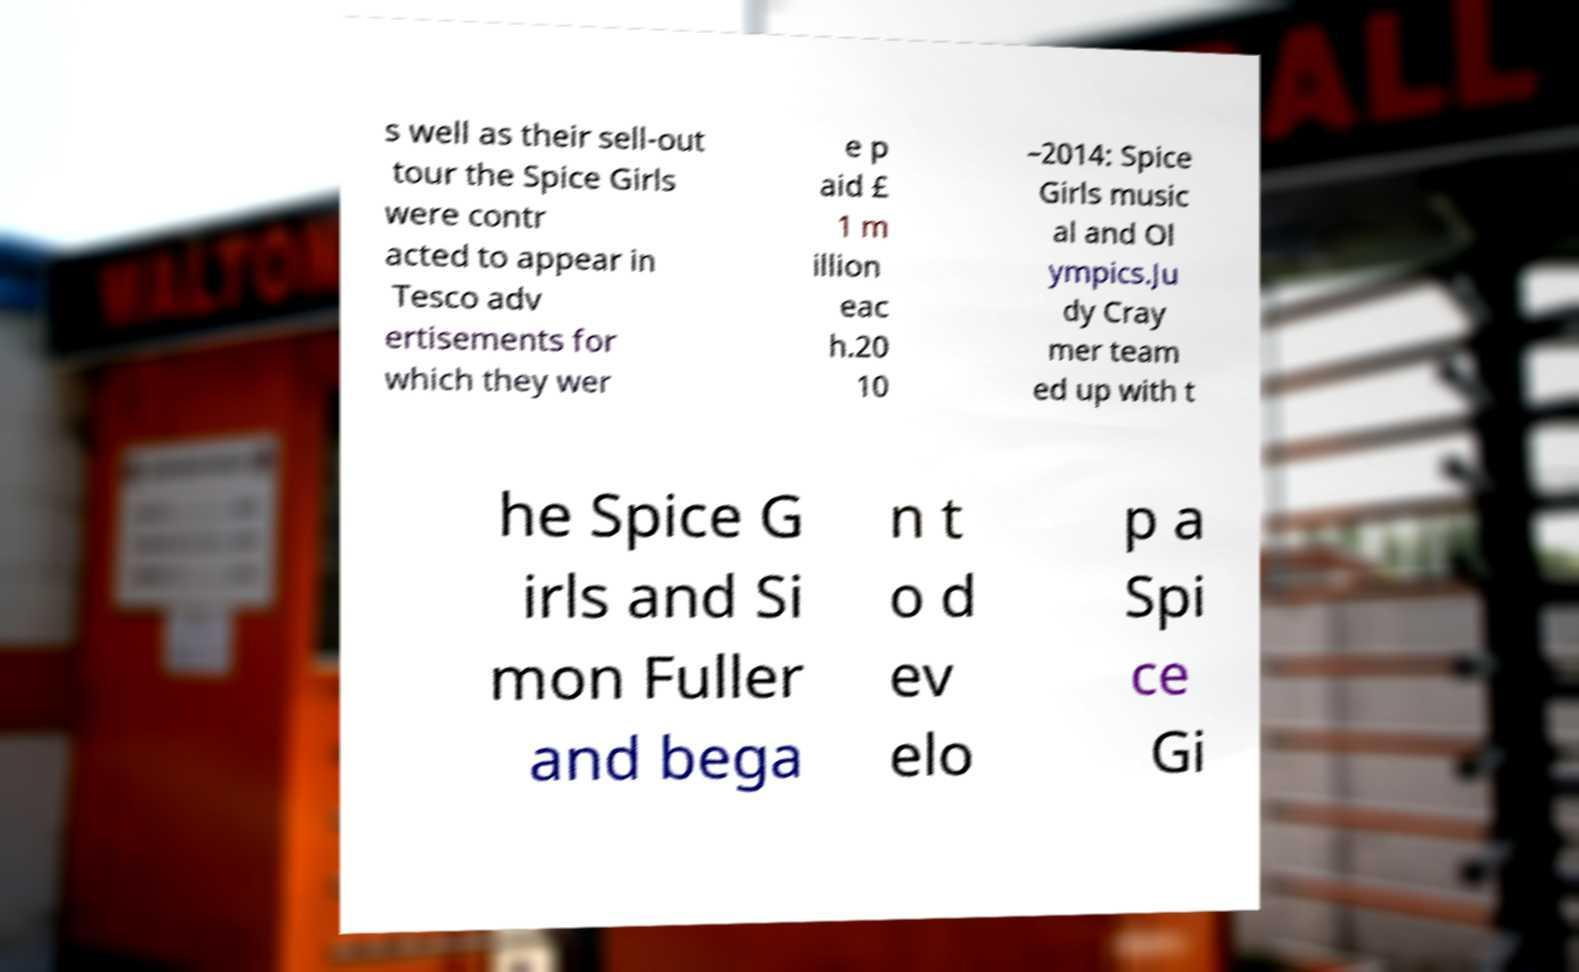Can you read and provide the text displayed in the image?This photo seems to have some interesting text. Can you extract and type it out for me? s well as their sell-out tour the Spice Girls were contr acted to appear in Tesco adv ertisements for which they wer e p aid £ 1 m illion eac h.20 10 –2014: Spice Girls music al and Ol ympics.Ju dy Cray mer team ed up with t he Spice G irls and Si mon Fuller and bega n t o d ev elo p a Spi ce Gi 